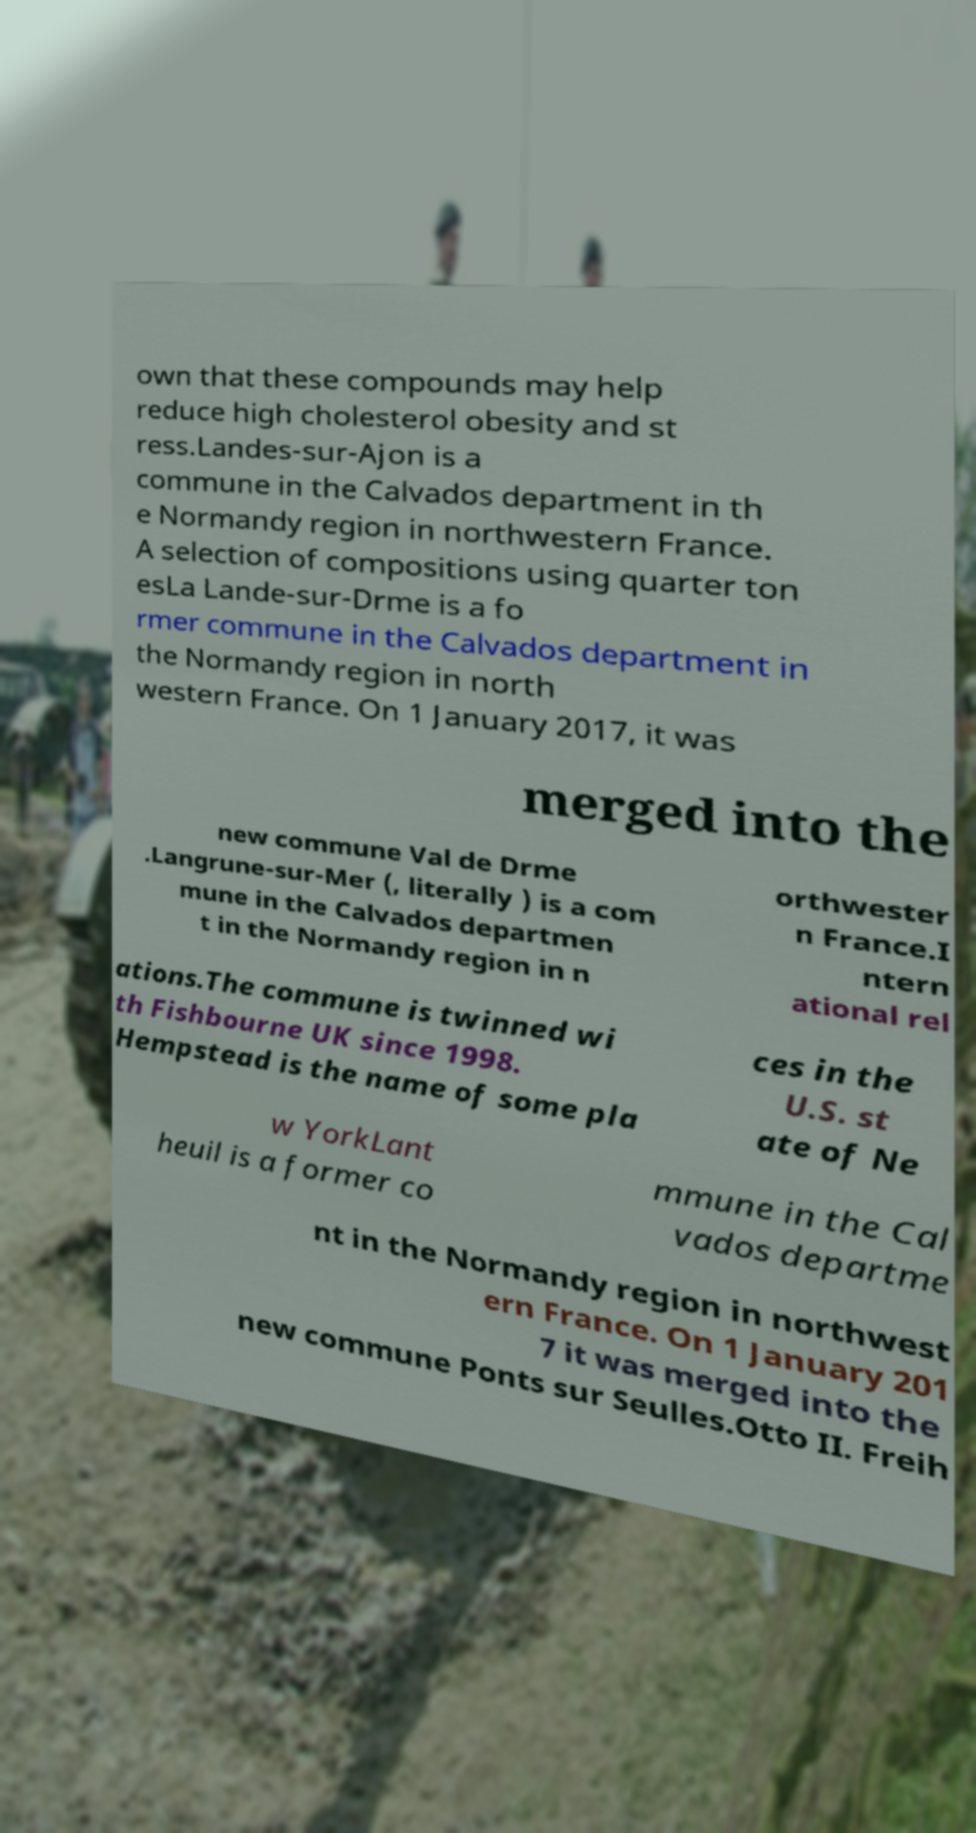Please read and relay the text visible in this image. What does it say? own that these compounds may help reduce high cholesterol obesity and st ress.Landes-sur-Ajon is a commune in the Calvados department in th e Normandy region in northwestern France. A selection of compositions using quarter ton esLa Lande-sur-Drme is a fo rmer commune in the Calvados department in the Normandy region in north western France. On 1 January 2017, it was merged into the new commune Val de Drme .Langrune-sur-Mer (, literally ) is a com mune in the Calvados departmen t in the Normandy region in n orthwester n France.I ntern ational rel ations.The commune is twinned wi th Fishbourne UK since 1998. Hempstead is the name of some pla ces in the U.S. st ate of Ne w YorkLant heuil is a former co mmune in the Cal vados departme nt in the Normandy region in northwest ern France. On 1 January 201 7 it was merged into the new commune Ponts sur Seulles.Otto II. Freih 